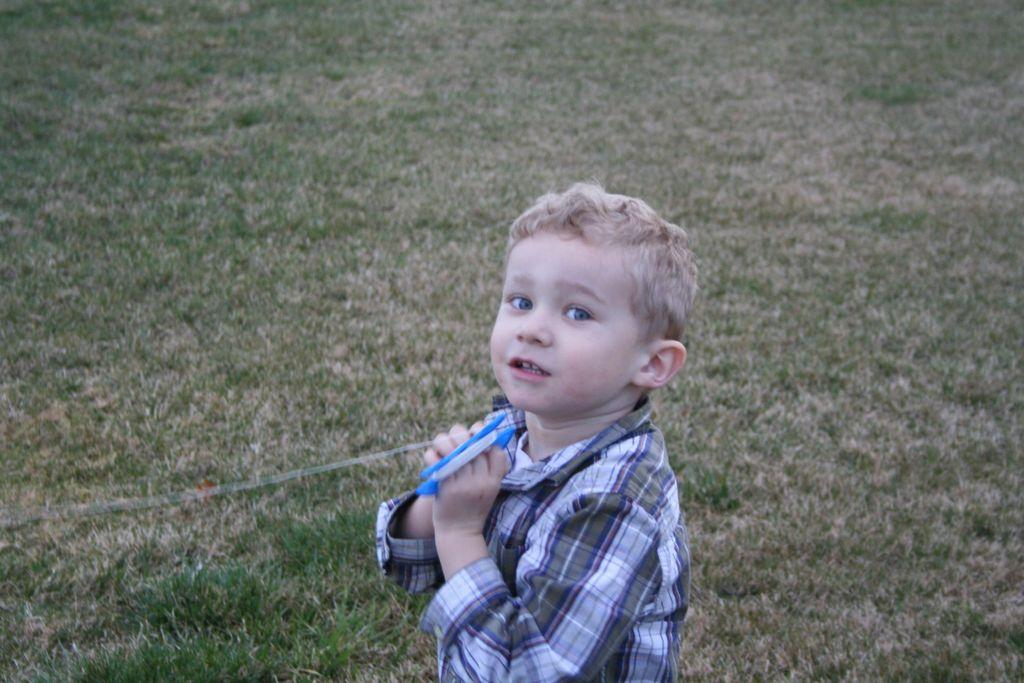What is the main subject of the image? The main subject of the image is a kid. What is the kid wearing in the image? The kid is wearing clothes in the image. What type of surface is visible on the ground in the image? There is grass on the ground in the image. What type of connection can be seen between the kid and the hammer in the image? There is no hammer present in the image, so there is no connection between the kid and a hammer. 